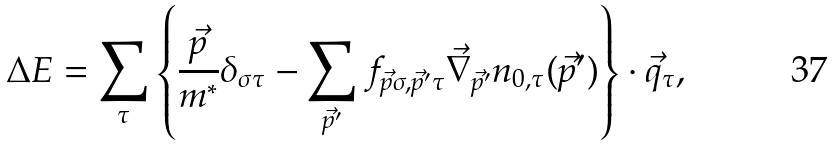Convert formula to latex. <formula><loc_0><loc_0><loc_500><loc_500>\Delta E = \sum _ { \tau } \left \{ \frac { \vec { p } } { m ^ { * } } \delta _ { \sigma \tau } - \sum _ { \vec { p } ^ { \prime } } f _ { \vec { p } \sigma , \vec { p } ^ { \prime } \tau } \vec { \nabla } _ { \vec { p } ^ { \prime } } n _ { 0 , \tau } ( { \vec { p } ^ { \prime } } ) \right \} \cdot { \vec { q } } _ { \tau } ,</formula> 